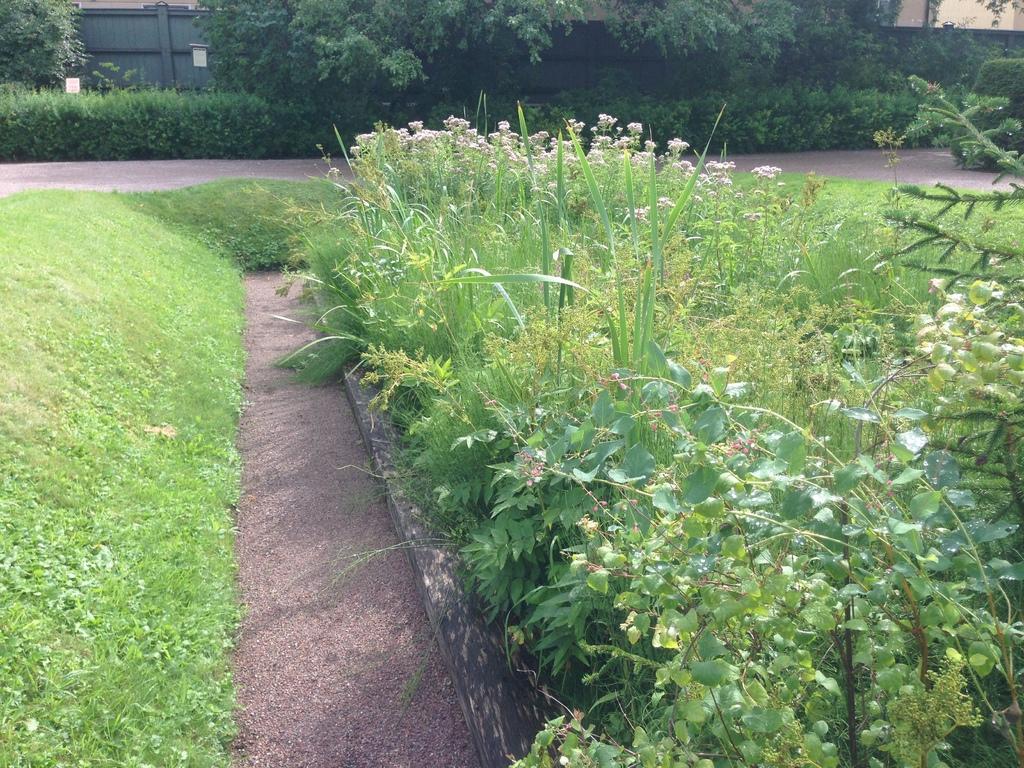In one or two sentences, can you explain what this image depicts? In this image, we can see trees, plants, boards and there are sheds. At the bottom, there is ground. 